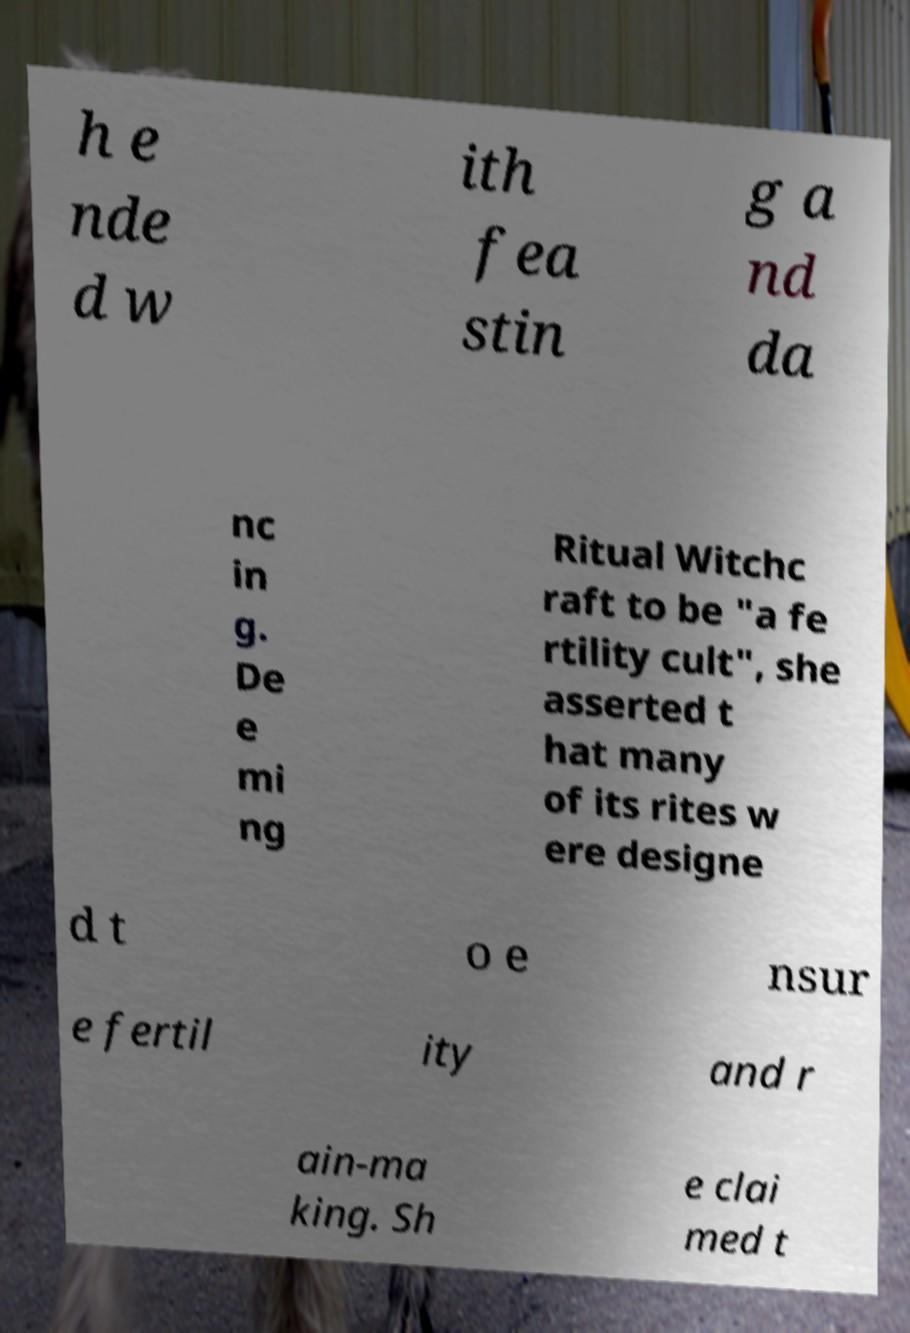Could you assist in decoding the text presented in this image and type it out clearly? h e nde d w ith fea stin g a nd da nc in g. De e mi ng Ritual Witchc raft to be "a fe rtility cult", she asserted t hat many of its rites w ere designe d t o e nsur e fertil ity and r ain-ma king. Sh e clai med t 